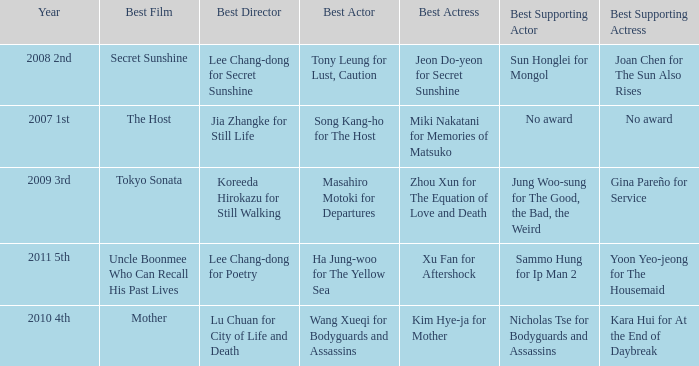Name the best director for mother Lu Chuan for City of Life and Death. 